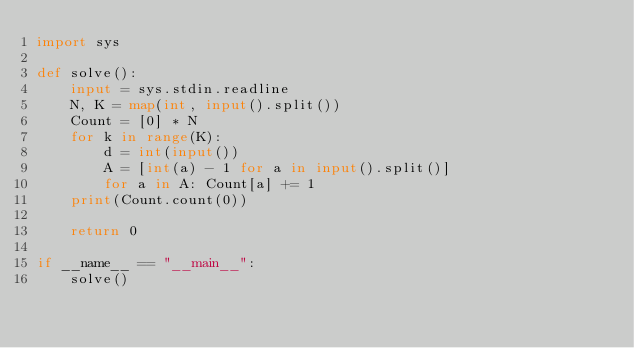Convert code to text. <code><loc_0><loc_0><loc_500><loc_500><_Python_>import sys

def solve():
    input = sys.stdin.readline
    N, K = map(int, input().split())
    Count = [0] * N
    for k in range(K):
        d = int(input())
        A = [int(a) - 1 for a in input().split()]
        for a in A: Count[a] += 1
    print(Count.count(0))

    return 0

if __name__ == "__main__":
    solve()</code> 